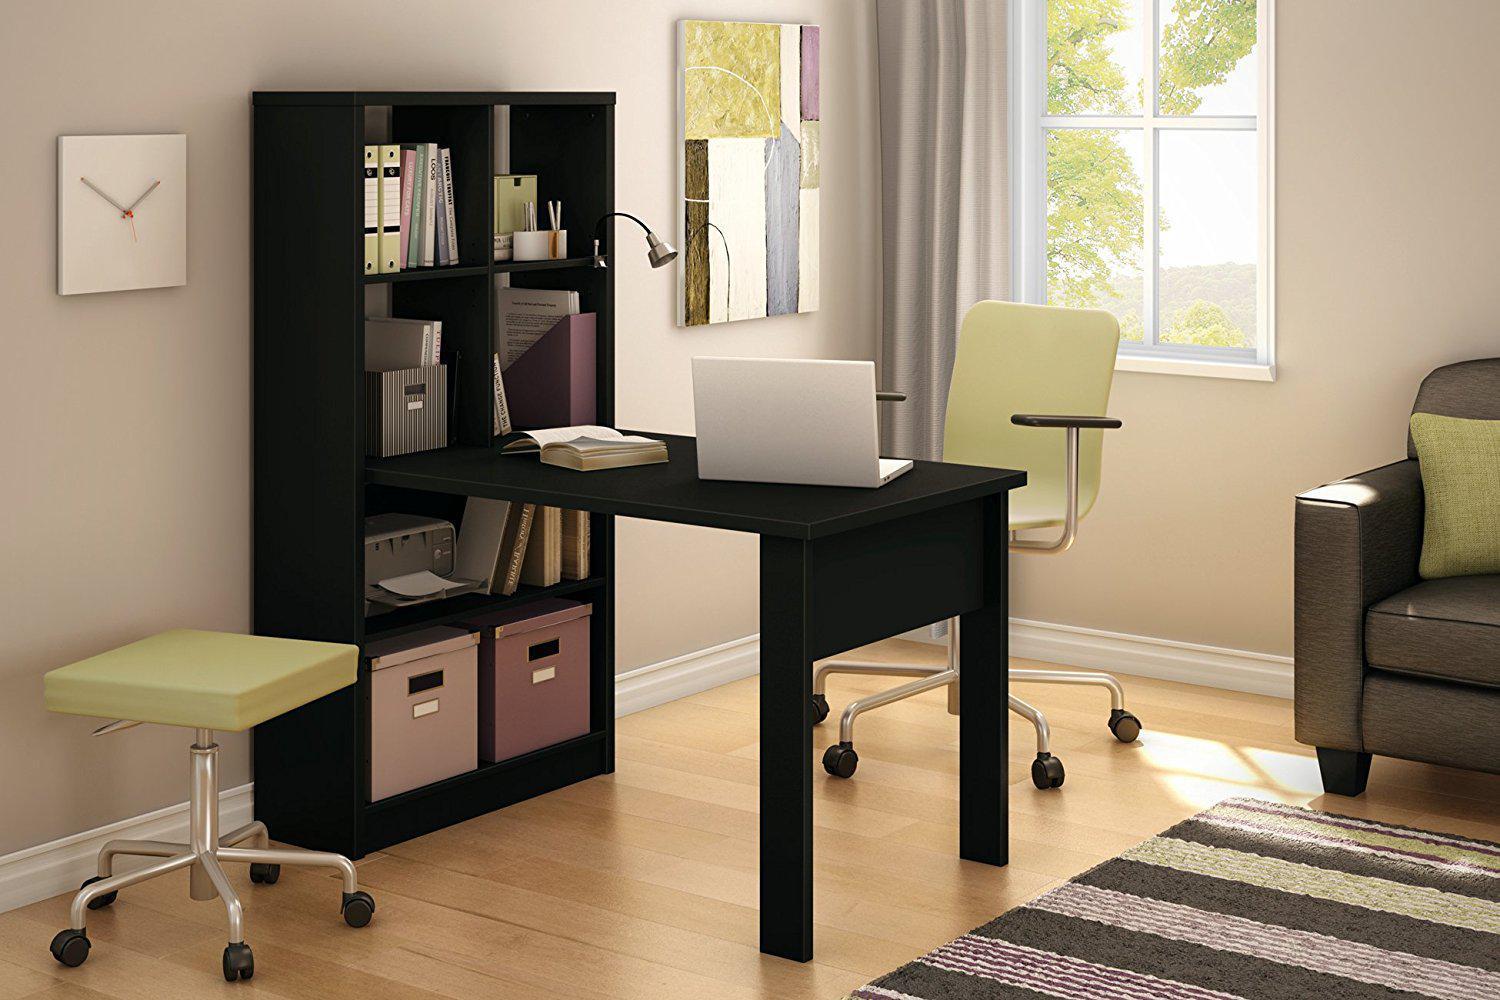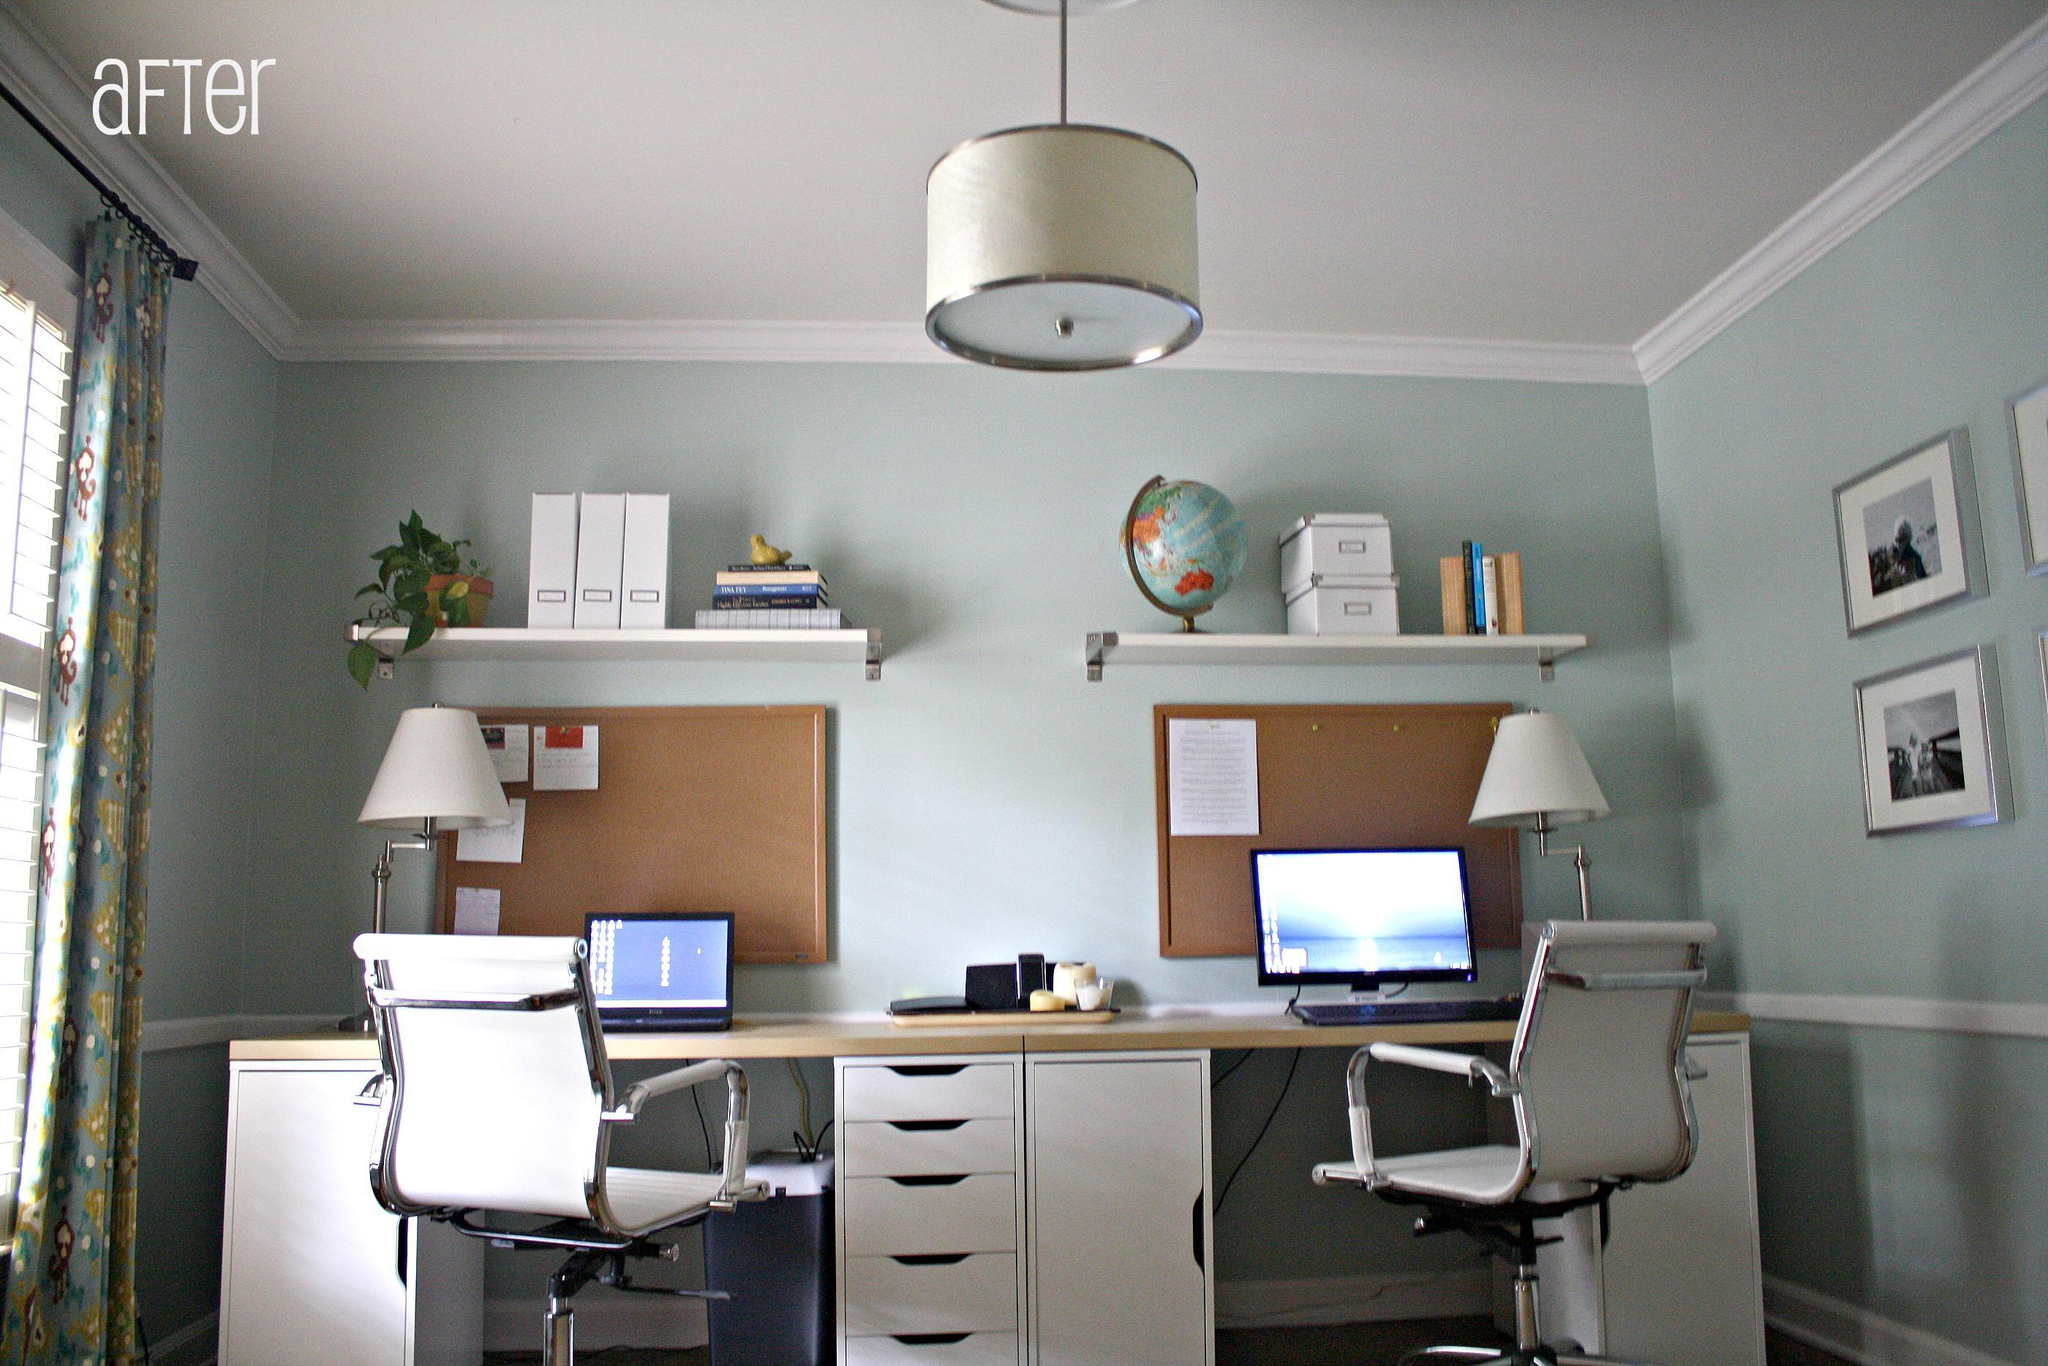The first image is the image on the left, the second image is the image on the right. Examine the images to the left and right. Is the description "The left image shows a table that extends out from a bookshelf against a wall with divided square compartments containing some upright books." accurate? Answer yes or no. Yes. 